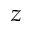Convert formula to latex. <formula><loc_0><loc_0><loc_500><loc_500>z</formula> 